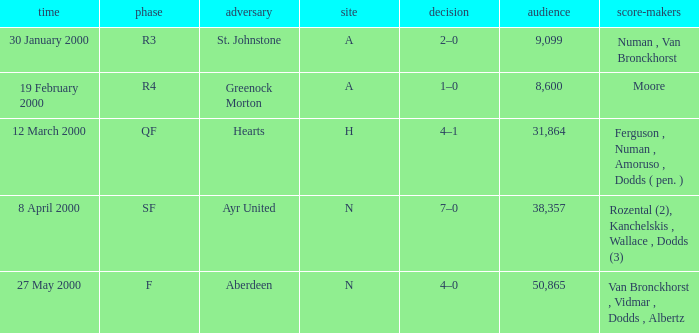Who was in a with opponent St. Johnstone? Numan , Van Bronckhorst. 